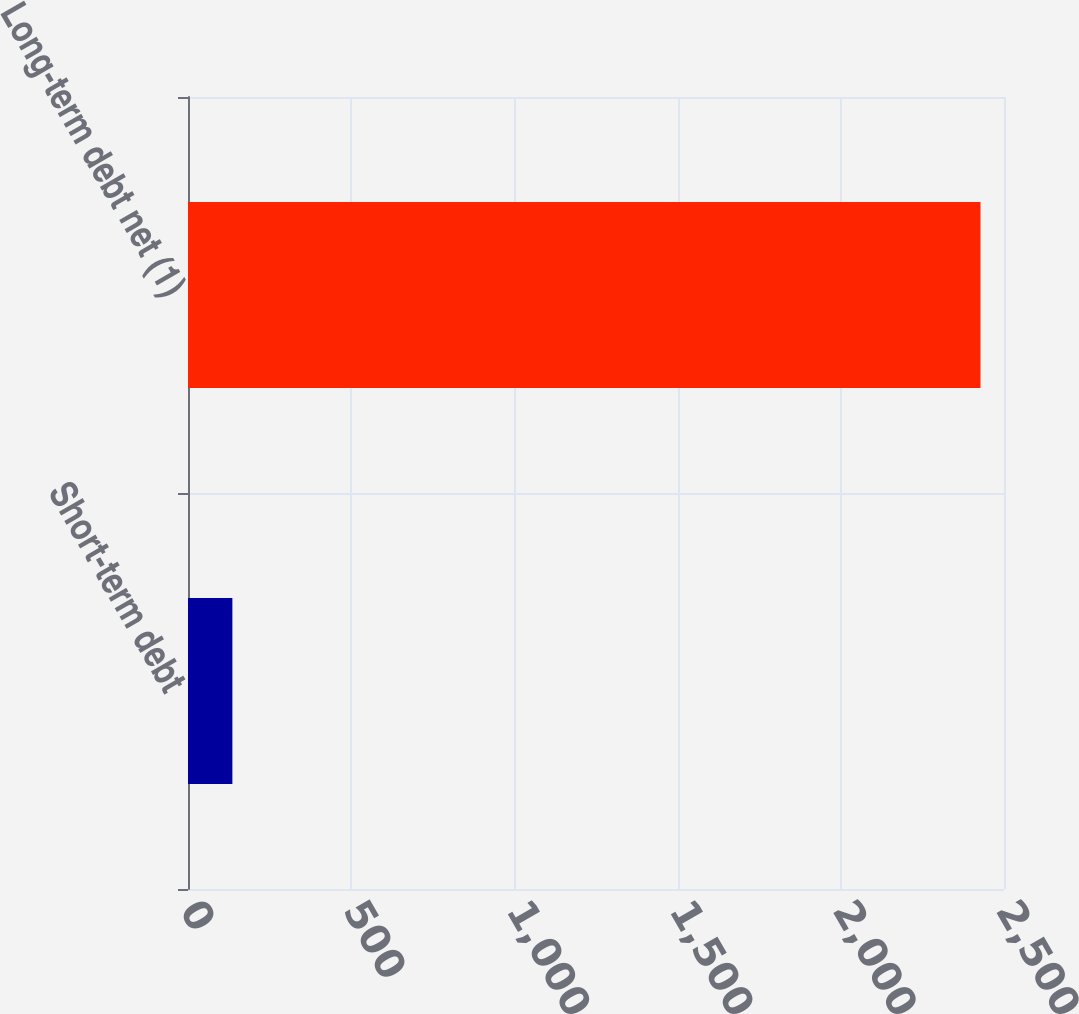<chart> <loc_0><loc_0><loc_500><loc_500><bar_chart><fcel>Short-term debt<fcel>Long-term debt net (1)<nl><fcel>136<fcel>2428<nl></chart> 